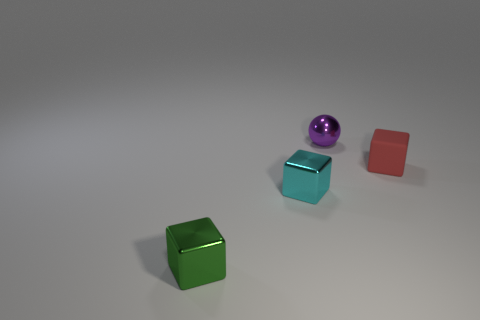Add 1 purple metal objects. How many objects exist? 5 Subtract all spheres. How many objects are left? 3 Add 2 purple balls. How many purple balls exist? 3 Subtract 0 gray balls. How many objects are left? 4 Subtract all small cyan spheres. Subtract all tiny purple metallic balls. How many objects are left? 3 Add 3 tiny green metallic cubes. How many tiny green metallic cubes are left? 4 